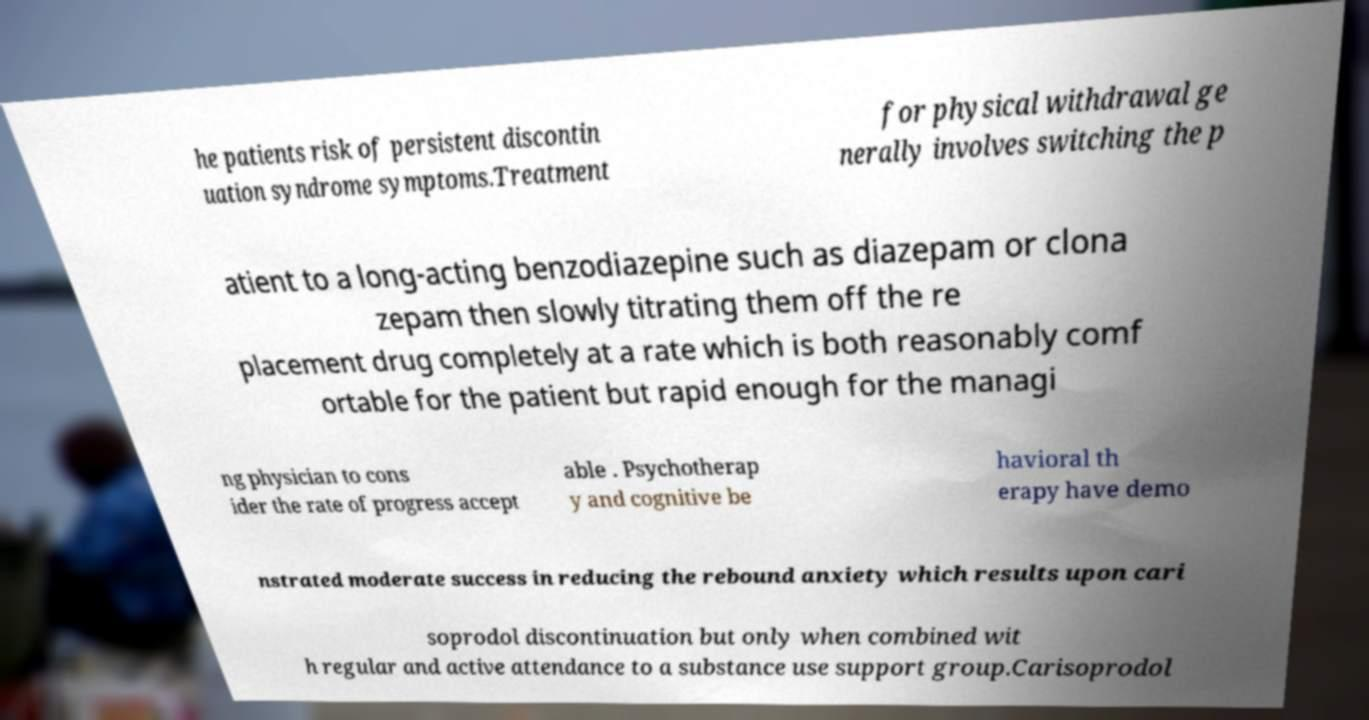Could you assist in decoding the text presented in this image and type it out clearly? he patients risk of persistent discontin uation syndrome symptoms.Treatment for physical withdrawal ge nerally involves switching the p atient to a long-acting benzodiazepine such as diazepam or clona zepam then slowly titrating them off the re placement drug completely at a rate which is both reasonably comf ortable for the patient but rapid enough for the managi ng physician to cons ider the rate of progress accept able . Psychotherap y and cognitive be havioral th erapy have demo nstrated moderate success in reducing the rebound anxiety which results upon cari soprodol discontinuation but only when combined wit h regular and active attendance to a substance use support group.Carisoprodol 